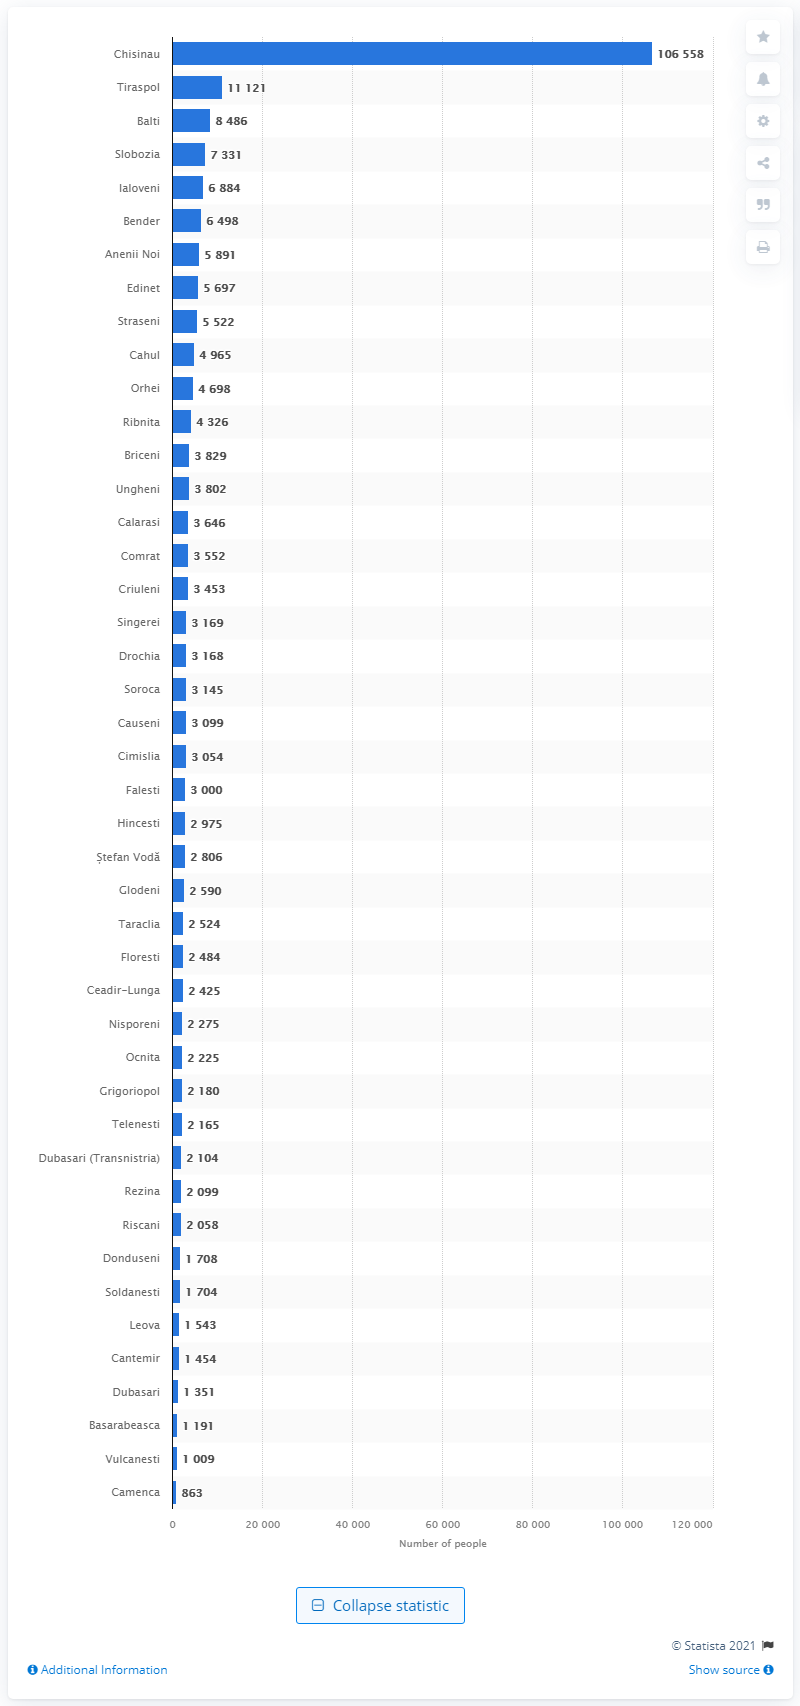Specify some key components in this picture. On June 29, 2021, the city of Chisinau had the highest number of confirmed cases of COVID-19 in the Republic of Moldova. The city of Baltimore was the third most affected by the COVID-19 pandemic. 